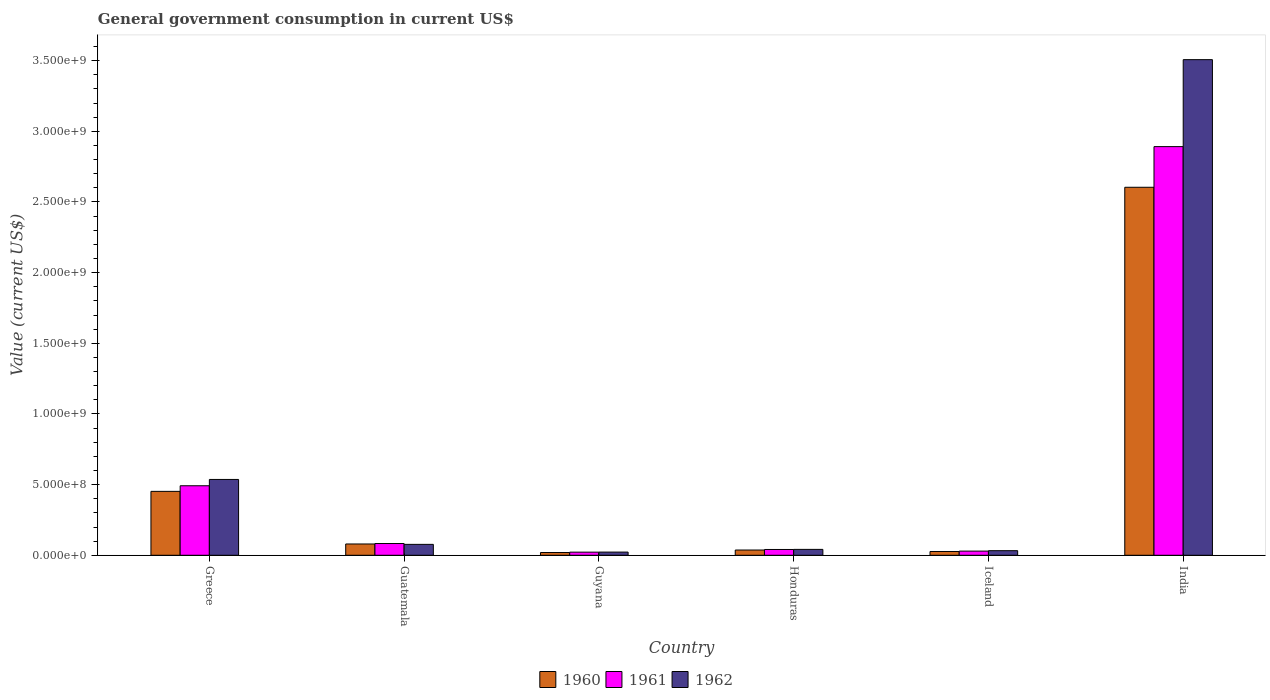How many different coloured bars are there?
Make the answer very short. 3. How many bars are there on the 2nd tick from the left?
Provide a short and direct response. 3. What is the label of the 2nd group of bars from the left?
Your answer should be compact. Guatemala. What is the government conusmption in 1962 in India?
Your answer should be very brief. 3.51e+09. Across all countries, what is the maximum government conusmption in 1961?
Make the answer very short. 2.89e+09. Across all countries, what is the minimum government conusmption in 1960?
Your answer should be very brief. 1.95e+07. In which country was the government conusmption in 1960 maximum?
Offer a very short reply. India. In which country was the government conusmption in 1961 minimum?
Your response must be concise. Guyana. What is the total government conusmption in 1962 in the graph?
Offer a very short reply. 4.22e+09. What is the difference between the government conusmption in 1962 in Honduras and that in India?
Offer a very short reply. -3.47e+09. What is the difference between the government conusmption in 1962 in Guyana and the government conusmption in 1961 in India?
Make the answer very short. -2.87e+09. What is the average government conusmption in 1961 per country?
Give a very brief answer. 5.93e+08. What is the difference between the government conusmption of/in 1960 and government conusmption of/in 1962 in Guatemala?
Ensure brevity in your answer.  2.70e+06. What is the ratio of the government conusmption in 1961 in Greece to that in Guatemala?
Your answer should be compact. 5.92. Is the government conusmption in 1961 in Guyana less than that in Iceland?
Keep it short and to the point. Yes. Is the difference between the government conusmption in 1960 in Iceland and India greater than the difference between the government conusmption in 1962 in Iceland and India?
Ensure brevity in your answer.  Yes. What is the difference between the highest and the second highest government conusmption in 1961?
Make the answer very short. -2.81e+09. What is the difference between the highest and the lowest government conusmption in 1961?
Make the answer very short. 2.87e+09. In how many countries, is the government conusmption in 1960 greater than the average government conusmption in 1960 taken over all countries?
Your response must be concise. 1. Is the sum of the government conusmption in 1962 in Iceland and India greater than the maximum government conusmption in 1960 across all countries?
Offer a very short reply. Yes. What does the 1st bar from the left in Guatemala represents?
Make the answer very short. 1960. Are all the bars in the graph horizontal?
Keep it short and to the point. No. How many countries are there in the graph?
Ensure brevity in your answer.  6. Where does the legend appear in the graph?
Keep it short and to the point. Bottom center. How are the legend labels stacked?
Offer a terse response. Horizontal. What is the title of the graph?
Offer a terse response. General government consumption in current US$. What is the label or title of the X-axis?
Provide a succinct answer. Country. What is the label or title of the Y-axis?
Offer a terse response. Value (current US$). What is the Value (current US$) in 1960 in Greece?
Give a very brief answer. 4.52e+08. What is the Value (current US$) of 1961 in Greece?
Provide a short and direct response. 4.92e+08. What is the Value (current US$) in 1962 in Greece?
Keep it short and to the point. 5.37e+08. What is the Value (current US$) of 1960 in Guatemala?
Your answer should be very brief. 7.99e+07. What is the Value (current US$) in 1961 in Guatemala?
Give a very brief answer. 8.31e+07. What is the Value (current US$) in 1962 in Guatemala?
Keep it short and to the point. 7.72e+07. What is the Value (current US$) of 1960 in Guyana?
Your response must be concise. 1.95e+07. What is the Value (current US$) of 1961 in Guyana?
Ensure brevity in your answer.  2.22e+07. What is the Value (current US$) of 1962 in Guyana?
Keep it short and to the point. 2.25e+07. What is the Value (current US$) of 1960 in Honduras?
Ensure brevity in your answer.  3.72e+07. What is the Value (current US$) of 1961 in Honduras?
Provide a short and direct response. 4.10e+07. What is the Value (current US$) in 1962 in Honduras?
Your answer should be very brief. 4.16e+07. What is the Value (current US$) in 1960 in Iceland?
Your answer should be compact. 2.68e+07. What is the Value (current US$) in 1961 in Iceland?
Make the answer very short. 2.95e+07. What is the Value (current US$) of 1962 in Iceland?
Provide a succinct answer. 3.25e+07. What is the Value (current US$) in 1960 in India?
Provide a succinct answer. 2.60e+09. What is the Value (current US$) in 1961 in India?
Keep it short and to the point. 2.89e+09. What is the Value (current US$) of 1962 in India?
Your response must be concise. 3.51e+09. Across all countries, what is the maximum Value (current US$) in 1960?
Your answer should be compact. 2.60e+09. Across all countries, what is the maximum Value (current US$) of 1961?
Offer a terse response. 2.89e+09. Across all countries, what is the maximum Value (current US$) of 1962?
Keep it short and to the point. 3.51e+09. Across all countries, what is the minimum Value (current US$) in 1960?
Make the answer very short. 1.95e+07. Across all countries, what is the minimum Value (current US$) in 1961?
Provide a short and direct response. 2.22e+07. Across all countries, what is the minimum Value (current US$) of 1962?
Your answer should be compact. 2.25e+07. What is the total Value (current US$) of 1960 in the graph?
Offer a very short reply. 3.22e+09. What is the total Value (current US$) in 1961 in the graph?
Offer a terse response. 3.56e+09. What is the total Value (current US$) in 1962 in the graph?
Make the answer very short. 4.22e+09. What is the difference between the Value (current US$) of 1960 in Greece and that in Guatemala?
Your answer should be compact. 3.72e+08. What is the difference between the Value (current US$) of 1961 in Greece and that in Guatemala?
Your response must be concise. 4.09e+08. What is the difference between the Value (current US$) in 1962 in Greece and that in Guatemala?
Your answer should be compact. 4.59e+08. What is the difference between the Value (current US$) of 1960 in Greece and that in Guyana?
Your answer should be very brief. 4.33e+08. What is the difference between the Value (current US$) of 1961 in Greece and that in Guyana?
Give a very brief answer. 4.70e+08. What is the difference between the Value (current US$) of 1962 in Greece and that in Guyana?
Provide a succinct answer. 5.14e+08. What is the difference between the Value (current US$) of 1960 in Greece and that in Honduras?
Provide a succinct answer. 4.15e+08. What is the difference between the Value (current US$) in 1961 in Greece and that in Honduras?
Give a very brief answer. 4.51e+08. What is the difference between the Value (current US$) of 1962 in Greece and that in Honduras?
Give a very brief answer. 4.95e+08. What is the difference between the Value (current US$) in 1960 in Greece and that in Iceland?
Provide a succinct answer. 4.25e+08. What is the difference between the Value (current US$) in 1961 in Greece and that in Iceland?
Provide a succinct answer. 4.62e+08. What is the difference between the Value (current US$) in 1962 in Greece and that in Iceland?
Keep it short and to the point. 5.04e+08. What is the difference between the Value (current US$) in 1960 in Greece and that in India?
Ensure brevity in your answer.  -2.15e+09. What is the difference between the Value (current US$) of 1961 in Greece and that in India?
Provide a succinct answer. -2.40e+09. What is the difference between the Value (current US$) in 1962 in Greece and that in India?
Your answer should be very brief. -2.97e+09. What is the difference between the Value (current US$) in 1960 in Guatemala and that in Guyana?
Offer a very short reply. 6.04e+07. What is the difference between the Value (current US$) in 1961 in Guatemala and that in Guyana?
Offer a terse response. 6.09e+07. What is the difference between the Value (current US$) in 1962 in Guatemala and that in Guyana?
Your answer should be compact. 5.47e+07. What is the difference between the Value (current US$) of 1960 in Guatemala and that in Honduras?
Keep it short and to the point. 4.28e+07. What is the difference between the Value (current US$) of 1961 in Guatemala and that in Honduras?
Make the answer very short. 4.20e+07. What is the difference between the Value (current US$) of 1962 in Guatemala and that in Honduras?
Offer a very short reply. 3.56e+07. What is the difference between the Value (current US$) of 1960 in Guatemala and that in Iceland?
Your answer should be compact. 5.31e+07. What is the difference between the Value (current US$) of 1961 in Guatemala and that in Iceland?
Ensure brevity in your answer.  5.36e+07. What is the difference between the Value (current US$) of 1962 in Guatemala and that in Iceland?
Offer a terse response. 4.47e+07. What is the difference between the Value (current US$) in 1960 in Guatemala and that in India?
Your answer should be compact. -2.52e+09. What is the difference between the Value (current US$) in 1961 in Guatemala and that in India?
Give a very brief answer. -2.81e+09. What is the difference between the Value (current US$) of 1962 in Guatemala and that in India?
Your response must be concise. -3.43e+09. What is the difference between the Value (current US$) of 1960 in Guyana and that in Honduras?
Give a very brief answer. -1.77e+07. What is the difference between the Value (current US$) in 1961 in Guyana and that in Honduras?
Ensure brevity in your answer.  -1.89e+07. What is the difference between the Value (current US$) of 1962 in Guyana and that in Honduras?
Give a very brief answer. -1.91e+07. What is the difference between the Value (current US$) of 1960 in Guyana and that in Iceland?
Provide a succinct answer. -7.28e+06. What is the difference between the Value (current US$) of 1961 in Guyana and that in Iceland?
Make the answer very short. -7.36e+06. What is the difference between the Value (current US$) of 1962 in Guyana and that in Iceland?
Keep it short and to the point. -1.00e+07. What is the difference between the Value (current US$) of 1960 in Guyana and that in India?
Make the answer very short. -2.58e+09. What is the difference between the Value (current US$) of 1961 in Guyana and that in India?
Keep it short and to the point. -2.87e+09. What is the difference between the Value (current US$) of 1962 in Guyana and that in India?
Offer a very short reply. -3.48e+09. What is the difference between the Value (current US$) in 1960 in Honduras and that in Iceland?
Ensure brevity in your answer.  1.04e+07. What is the difference between the Value (current US$) in 1961 in Honduras and that in Iceland?
Keep it short and to the point. 1.15e+07. What is the difference between the Value (current US$) in 1962 in Honduras and that in Iceland?
Your answer should be very brief. 9.12e+06. What is the difference between the Value (current US$) of 1960 in Honduras and that in India?
Your answer should be very brief. -2.57e+09. What is the difference between the Value (current US$) of 1961 in Honduras and that in India?
Ensure brevity in your answer.  -2.85e+09. What is the difference between the Value (current US$) of 1962 in Honduras and that in India?
Ensure brevity in your answer.  -3.47e+09. What is the difference between the Value (current US$) in 1960 in Iceland and that in India?
Provide a short and direct response. -2.58e+09. What is the difference between the Value (current US$) in 1961 in Iceland and that in India?
Your response must be concise. -2.86e+09. What is the difference between the Value (current US$) in 1962 in Iceland and that in India?
Your answer should be compact. -3.47e+09. What is the difference between the Value (current US$) in 1960 in Greece and the Value (current US$) in 1961 in Guatemala?
Provide a short and direct response. 3.69e+08. What is the difference between the Value (current US$) in 1960 in Greece and the Value (current US$) in 1962 in Guatemala?
Keep it short and to the point. 3.75e+08. What is the difference between the Value (current US$) of 1961 in Greece and the Value (current US$) of 1962 in Guatemala?
Your answer should be compact. 4.15e+08. What is the difference between the Value (current US$) of 1960 in Greece and the Value (current US$) of 1961 in Guyana?
Provide a short and direct response. 4.30e+08. What is the difference between the Value (current US$) of 1960 in Greece and the Value (current US$) of 1962 in Guyana?
Your response must be concise. 4.30e+08. What is the difference between the Value (current US$) of 1961 in Greece and the Value (current US$) of 1962 in Guyana?
Your answer should be compact. 4.69e+08. What is the difference between the Value (current US$) of 1960 in Greece and the Value (current US$) of 1961 in Honduras?
Make the answer very short. 4.11e+08. What is the difference between the Value (current US$) of 1960 in Greece and the Value (current US$) of 1962 in Honduras?
Make the answer very short. 4.11e+08. What is the difference between the Value (current US$) of 1961 in Greece and the Value (current US$) of 1962 in Honduras?
Your answer should be compact. 4.50e+08. What is the difference between the Value (current US$) of 1960 in Greece and the Value (current US$) of 1961 in Iceland?
Provide a short and direct response. 4.23e+08. What is the difference between the Value (current US$) of 1960 in Greece and the Value (current US$) of 1962 in Iceland?
Make the answer very short. 4.20e+08. What is the difference between the Value (current US$) of 1961 in Greece and the Value (current US$) of 1962 in Iceland?
Offer a terse response. 4.59e+08. What is the difference between the Value (current US$) in 1960 in Greece and the Value (current US$) in 1961 in India?
Keep it short and to the point. -2.44e+09. What is the difference between the Value (current US$) in 1960 in Greece and the Value (current US$) in 1962 in India?
Your answer should be compact. -3.05e+09. What is the difference between the Value (current US$) in 1961 in Greece and the Value (current US$) in 1962 in India?
Your answer should be very brief. -3.02e+09. What is the difference between the Value (current US$) in 1960 in Guatemala and the Value (current US$) in 1961 in Guyana?
Your answer should be very brief. 5.77e+07. What is the difference between the Value (current US$) of 1960 in Guatemala and the Value (current US$) of 1962 in Guyana?
Ensure brevity in your answer.  5.74e+07. What is the difference between the Value (current US$) in 1961 in Guatemala and the Value (current US$) in 1962 in Guyana?
Your answer should be compact. 6.06e+07. What is the difference between the Value (current US$) in 1960 in Guatemala and the Value (current US$) in 1961 in Honduras?
Make the answer very short. 3.88e+07. What is the difference between the Value (current US$) of 1960 in Guatemala and the Value (current US$) of 1962 in Honduras?
Your answer should be very brief. 3.82e+07. What is the difference between the Value (current US$) in 1961 in Guatemala and the Value (current US$) in 1962 in Honduras?
Ensure brevity in your answer.  4.14e+07. What is the difference between the Value (current US$) in 1960 in Guatemala and the Value (current US$) in 1961 in Iceland?
Give a very brief answer. 5.04e+07. What is the difference between the Value (current US$) in 1960 in Guatemala and the Value (current US$) in 1962 in Iceland?
Your answer should be compact. 4.74e+07. What is the difference between the Value (current US$) in 1961 in Guatemala and the Value (current US$) in 1962 in Iceland?
Make the answer very short. 5.06e+07. What is the difference between the Value (current US$) of 1960 in Guatemala and the Value (current US$) of 1961 in India?
Give a very brief answer. -2.81e+09. What is the difference between the Value (current US$) of 1960 in Guatemala and the Value (current US$) of 1962 in India?
Ensure brevity in your answer.  -3.43e+09. What is the difference between the Value (current US$) of 1961 in Guatemala and the Value (current US$) of 1962 in India?
Your answer should be very brief. -3.42e+09. What is the difference between the Value (current US$) in 1960 in Guyana and the Value (current US$) in 1961 in Honduras?
Make the answer very short. -2.16e+07. What is the difference between the Value (current US$) in 1960 in Guyana and the Value (current US$) in 1962 in Honduras?
Your answer should be very brief. -2.22e+07. What is the difference between the Value (current US$) in 1961 in Guyana and the Value (current US$) in 1962 in Honduras?
Provide a short and direct response. -1.95e+07. What is the difference between the Value (current US$) in 1960 in Guyana and the Value (current US$) in 1961 in Iceland?
Provide a short and direct response. -1.00e+07. What is the difference between the Value (current US$) of 1960 in Guyana and the Value (current US$) of 1962 in Iceland?
Offer a terse response. -1.30e+07. What is the difference between the Value (current US$) in 1961 in Guyana and the Value (current US$) in 1962 in Iceland?
Your answer should be compact. -1.04e+07. What is the difference between the Value (current US$) in 1960 in Guyana and the Value (current US$) in 1961 in India?
Ensure brevity in your answer.  -2.87e+09. What is the difference between the Value (current US$) in 1960 in Guyana and the Value (current US$) in 1962 in India?
Your response must be concise. -3.49e+09. What is the difference between the Value (current US$) in 1961 in Guyana and the Value (current US$) in 1962 in India?
Make the answer very short. -3.48e+09. What is the difference between the Value (current US$) in 1960 in Honduras and the Value (current US$) in 1961 in Iceland?
Keep it short and to the point. 7.62e+06. What is the difference between the Value (current US$) of 1960 in Honduras and the Value (current US$) of 1962 in Iceland?
Make the answer very short. 4.62e+06. What is the difference between the Value (current US$) in 1961 in Honduras and the Value (current US$) in 1962 in Iceland?
Give a very brief answer. 8.52e+06. What is the difference between the Value (current US$) of 1960 in Honduras and the Value (current US$) of 1961 in India?
Offer a terse response. -2.85e+09. What is the difference between the Value (current US$) in 1960 in Honduras and the Value (current US$) in 1962 in India?
Provide a succinct answer. -3.47e+09. What is the difference between the Value (current US$) in 1961 in Honduras and the Value (current US$) in 1962 in India?
Your answer should be very brief. -3.47e+09. What is the difference between the Value (current US$) in 1960 in Iceland and the Value (current US$) in 1961 in India?
Provide a succinct answer. -2.86e+09. What is the difference between the Value (current US$) in 1960 in Iceland and the Value (current US$) in 1962 in India?
Provide a succinct answer. -3.48e+09. What is the difference between the Value (current US$) in 1961 in Iceland and the Value (current US$) in 1962 in India?
Keep it short and to the point. -3.48e+09. What is the average Value (current US$) in 1960 per country?
Ensure brevity in your answer.  5.37e+08. What is the average Value (current US$) of 1961 per country?
Your response must be concise. 5.93e+08. What is the average Value (current US$) in 1962 per country?
Your answer should be very brief. 7.03e+08. What is the difference between the Value (current US$) in 1960 and Value (current US$) in 1961 in Greece?
Offer a very short reply. -3.96e+07. What is the difference between the Value (current US$) in 1960 and Value (current US$) in 1962 in Greece?
Your answer should be very brief. -8.43e+07. What is the difference between the Value (current US$) in 1961 and Value (current US$) in 1962 in Greece?
Your answer should be compact. -4.47e+07. What is the difference between the Value (current US$) in 1960 and Value (current US$) in 1961 in Guatemala?
Provide a short and direct response. -3.20e+06. What is the difference between the Value (current US$) of 1960 and Value (current US$) of 1962 in Guatemala?
Offer a very short reply. 2.70e+06. What is the difference between the Value (current US$) in 1961 and Value (current US$) in 1962 in Guatemala?
Keep it short and to the point. 5.90e+06. What is the difference between the Value (current US$) of 1960 and Value (current US$) of 1961 in Guyana?
Offer a terse response. -2.68e+06. What is the difference between the Value (current US$) of 1960 and Value (current US$) of 1962 in Guyana?
Make the answer very short. -3.03e+06. What is the difference between the Value (current US$) of 1961 and Value (current US$) of 1962 in Guyana?
Make the answer very short. -3.50e+05. What is the difference between the Value (current US$) of 1960 and Value (current US$) of 1961 in Honduras?
Your answer should be compact. -3.90e+06. What is the difference between the Value (current US$) in 1960 and Value (current US$) in 1962 in Honduras?
Make the answer very short. -4.50e+06. What is the difference between the Value (current US$) of 1961 and Value (current US$) of 1962 in Honduras?
Ensure brevity in your answer.  -6.00e+05. What is the difference between the Value (current US$) of 1960 and Value (current US$) of 1961 in Iceland?
Offer a terse response. -2.77e+06. What is the difference between the Value (current US$) in 1960 and Value (current US$) in 1962 in Iceland?
Your response must be concise. -5.77e+06. What is the difference between the Value (current US$) of 1961 and Value (current US$) of 1962 in Iceland?
Give a very brief answer. -3.00e+06. What is the difference between the Value (current US$) of 1960 and Value (current US$) of 1961 in India?
Your response must be concise. -2.88e+08. What is the difference between the Value (current US$) in 1960 and Value (current US$) in 1962 in India?
Make the answer very short. -9.03e+08. What is the difference between the Value (current US$) in 1961 and Value (current US$) in 1962 in India?
Offer a terse response. -6.15e+08. What is the ratio of the Value (current US$) in 1960 in Greece to that in Guatemala?
Provide a short and direct response. 5.66. What is the ratio of the Value (current US$) of 1961 in Greece to that in Guatemala?
Ensure brevity in your answer.  5.92. What is the ratio of the Value (current US$) of 1962 in Greece to that in Guatemala?
Provide a succinct answer. 6.95. What is the ratio of the Value (current US$) of 1960 in Greece to that in Guyana?
Your response must be concise. 23.21. What is the ratio of the Value (current US$) in 1961 in Greece to that in Guyana?
Ensure brevity in your answer.  22.19. What is the ratio of the Value (current US$) in 1962 in Greece to that in Guyana?
Your answer should be very brief. 23.83. What is the ratio of the Value (current US$) in 1960 in Greece to that in Honduras?
Give a very brief answer. 12.17. What is the ratio of the Value (current US$) in 1961 in Greece to that in Honduras?
Provide a short and direct response. 11.98. What is the ratio of the Value (current US$) in 1962 in Greece to that in Honduras?
Offer a very short reply. 12.88. What is the ratio of the Value (current US$) in 1960 in Greece to that in Iceland?
Make the answer very short. 16.9. What is the ratio of the Value (current US$) of 1961 in Greece to that in Iceland?
Give a very brief answer. 16.66. What is the ratio of the Value (current US$) of 1962 in Greece to that in Iceland?
Your answer should be compact. 16.49. What is the ratio of the Value (current US$) of 1960 in Greece to that in India?
Your response must be concise. 0.17. What is the ratio of the Value (current US$) in 1961 in Greece to that in India?
Your answer should be very brief. 0.17. What is the ratio of the Value (current US$) of 1962 in Greece to that in India?
Ensure brevity in your answer.  0.15. What is the ratio of the Value (current US$) in 1960 in Guatemala to that in Guyana?
Provide a succinct answer. 4.1. What is the ratio of the Value (current US$) of 1961 in Guatemala to that in Guyana?
Offer a very short reply. 3.75. What is the ratio of the Value (current US$) in 1962 in Guatemala to that in Guyana?
Your answer should be very brief. 3.43. What is the ratio of the Value (current US$) of 1960 in Guatemala to that in Honduras?
Offer a very short reply. 2.15. What is the ratio of the Value (current US$) of 1961 in Guatemala to that in Honduras?
Your response must be concise. 2.02. What is the ratio of the Value (current US$) in 1962 in Guatemala to that in Honduras?
Your response must be concise. 1.85. What is the ratio of the Value (current US$) of 1960 in Guatemala to that in Iceland?
Offer a terse response. 2.99. What is the ratio of the Value (current US$) in 1961 in Guatemala to that in Iceland?
Offer a very short reply. 2.81. What is the ratio of the Value (current US$) of 1962 in Guatemala to that in Iceland?
Provide a short and direct response. 2.37. What is the ratio of the Value (current US$) of 1960 in Guatemala to that in India?
Ensure brevity in your answer.  0.03. What is the ratio of the Value (current US$) of 1961 in Guatemala to that in India?
Make the answer very short. 0.03. What is the ratio of the Value (current US$) in 1962 in Guatemala to that in India?
Provide a short and direct response. 0.02. What is the ratio of the Value (current US$) of 1960 in Guyana to that in Honduras?
Provide a succinct answer. 0.52. What is the ratio of the Value (current US$) of 1961 in Guyana to that in Honduras?
Provide a short and direct response. 0.54. What is the ratio of the Value (current US$) in 1962 in Guyana to that in Honduras?
Your answer should be very brief. 0.54. What is the ratio of the Value (current US$) in 1960 in Guyana to that in Iceland?
Make the answer very short. 0.73. What is the ratio of the Value (current US$) of 1961 in Guyana to that in Iceland?
Offer a very short reply. 0.75. What is the ratio of the Value (current US$) in 1962 in Guyana to that in Iceland?
Your response must be concise. 0.69. What is the ratio of the Value (current US$) of 1960 in Guyana to that in India?
Your response must be concise. 0.01. What is the ratio of the Value (current US$) in 1961 in Guyana to that in India?
Your answer should be compact. 0.01. What is the ratio of the Value (current US$) of 1962 in Guyana to that in India?
Your answer should be compact. 0.01. What is the ratio of the Value (current US$) of 1960 in Honduras to that in Iceland?
Your answer should be compact. 1.39. What is the ratio of the Value (current US$) of 1961 in Honduras to that in Iceland?
Your answer should be very brief. 1.39. What is the ratio of the Value (current US$) of 1962 in Honduras to that in Iceland?
Your answer should be compact. 1.28. What is the ratio of the Value (current US$) in 1960 in Honduras to that in India?
Provide a succinct answer. 0.01. What is the ratio of the Value (current US$) in 1961 in Honduras to that in India?
Offer a terse response. 0.01. What is the ratio of the Value (current US$) in 1962 in Honduras to that in India?
Make the answer very short. 0.01. What is the ratio of the Value (current US$) of 1960 in Iceland to that in India?
Keep it short and to the point. 0.01. What is the ratio of the Value (current US$) in 1961 in Iceland to that in India?
Give a very brief answer. 0.01. What is the ratio of the Value (current US$) in 1962 in Iceland to that in India?
Provide a short and direct response. 0.01. What is the difference between the highest and the second highest Value (current US$) of 1960?
Provide a short and direct response. 2.15e+09. What is the difference between the highest and the second highest Value (current US$) in 1961?
Your response must be concise. 2.40e+09. What is the difference between the highest and the second highest Value (current US$) in 1962?
Your answer should be compact. 2.97e+09. What is the difference between the highest and the lowest Value (current US$) of 1960?
Make the answer very short. 2.58e+09. What is the difference between the highest and the lowest Value (current US$) of 1961?
Provide a succinct answer. 2.87e+09. What is the difference between the highest and the lowest Value (current US$) of 1962?
Offer a very short reply. 3.48e+09. 